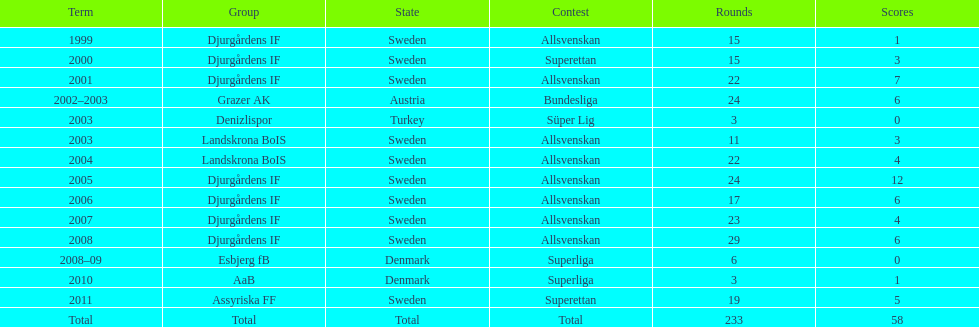What country is team djurgårdens if not from? Sweden. 